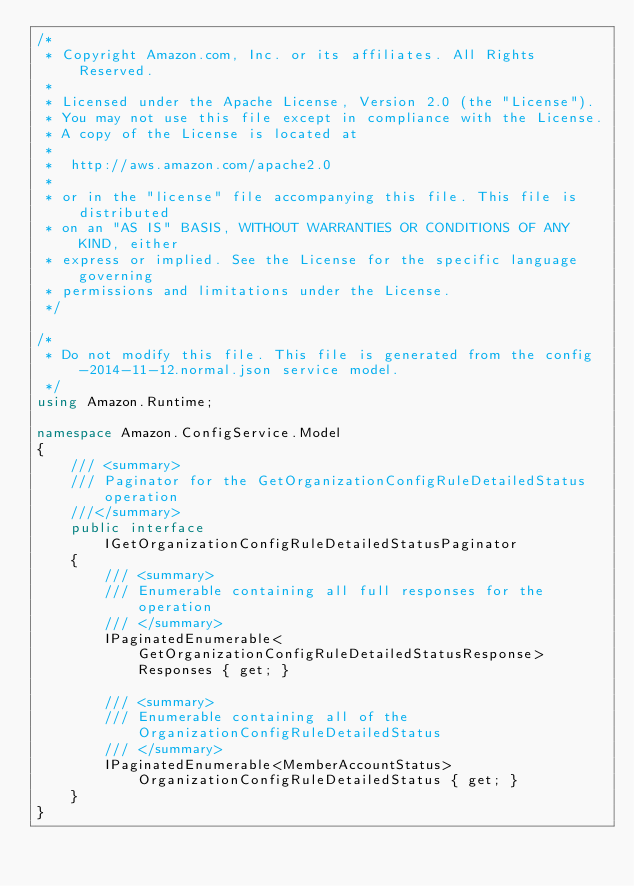Convert code to text. <code><loc_0><loc_0><loc_500><loc_500><_C#_>/*
 * Copyright Amazon.com, Inc. or its affiliates. All Rights Reserved.
 * 
 * Licensed under the Apache License, Version 2.0 (the "License").
 * You may not use this file except in compliance with the License.
 * A copy of the License is located at
 * 
 *  http://aws.amazon.com/apache2.0
 * 
 * or in the "license" file accompanying this file. This file is distributed
 * on an "AS IS" BASIS, WITHOUT WARRANTIES OR CONDITIONS OF ANY KIND, either
 * express or implied. See the License for the specific language governing
 * permissions and limitations under the License.
 */

/*
 * Do not modify this file. This file is generated from the config-2014-11-12.normal.json service model.
 */
using Amazon.Runtime;

namespace Amazon.ConfigService.Model
{
    /// <summary>
    /// Paginator for the GetOrganizationConfigRuleDetailedStatus operation
    ///</summary>
    public interface IGetOrganizationConfigRuleDetailedStatusPaginator
    {
        /// <summary>
        /// Enumerable containing all full responses for the operation
        /// </summary>
        IPaginatedEnumerable<GetOrganizationConfigRuleDetailedStatusResponse> Responses { get; }

        /// <summary>
        /// Enumerable containing all of the OrganizationConfigRuleDetailedStatus
        /// </summary>
        IPaginatedEnumerable<MemberAccountStatus> OrganizationConfigRuleDetailedStatus { get; }
    }
}</code> 